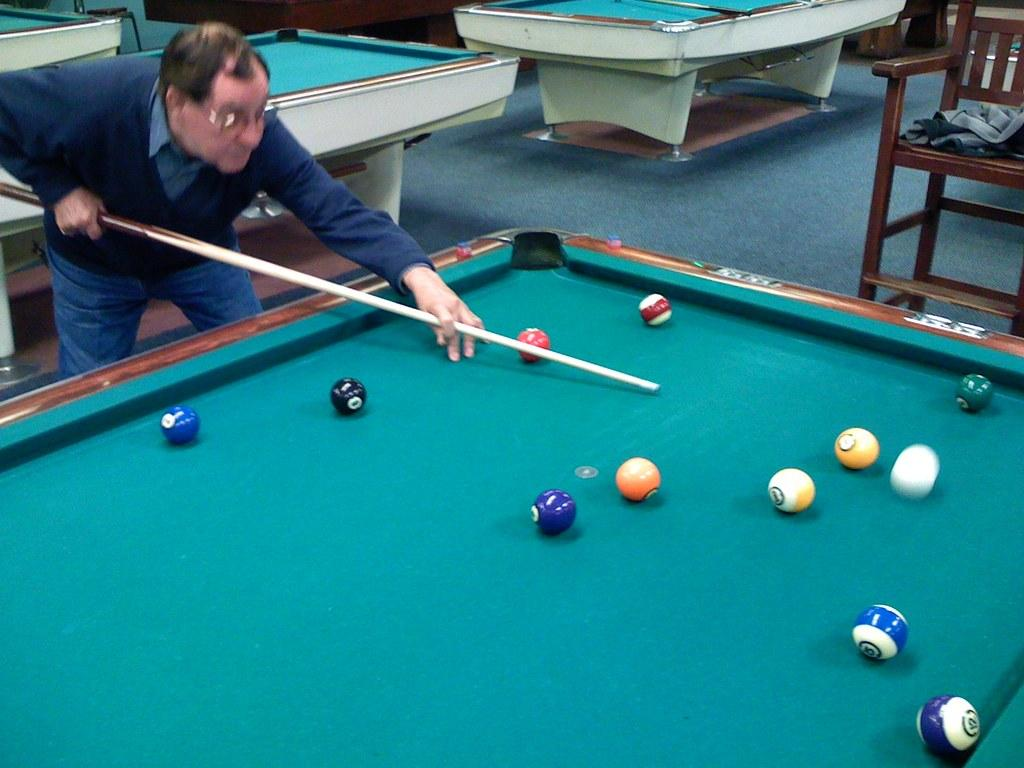What type of game is being played in the room? There are multiple snooker tables in the room, and a man is playing a game on one of them. How many snooker tables are in the room? There are multiple snooker tables in the room. What is the position of the chair in relation to the table where the man is playing? There is a chair beside the table where the man is playing. What is on the chair? There is a jacket on the chair. Can you see a dock in the room where the snooker game is being played? No, there is no dock present in the room; it is a snooker room with multiple tables and a man playing a game. 